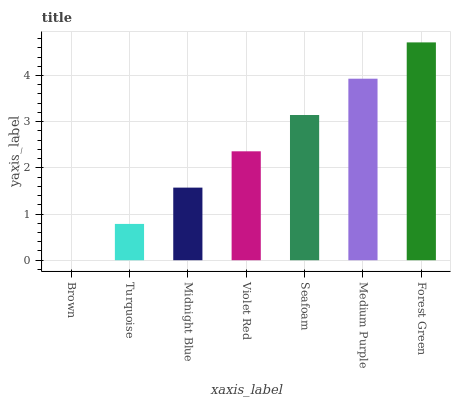Is Brown the minimum?
Answer yes or no. Yes. Is Forest Green the maximum?
Answer yes or no. Yes. Is Turquoise the minimum?
Answer yes or no. No. Is Turquoise the maximum?
Answer yes or no. No. Is Turquoise greater than Brown?
Answer yes or no. Yes. Is Brown less than Turquoise?
Answer yes or no. Yes. Is Brown greater than Turquoise?
Answer yes or no. No. Is Turquoise less than Brown?
Answer yes or no. No. Is Violet Red the high median?
Answer yes or no. Yes. Is Violet Red the low median?
Answer yes or no. Yes. Is Brown the high median?
Answer yes or no. No. Is Medium Purple the low median?
Answer yes or no. No. 